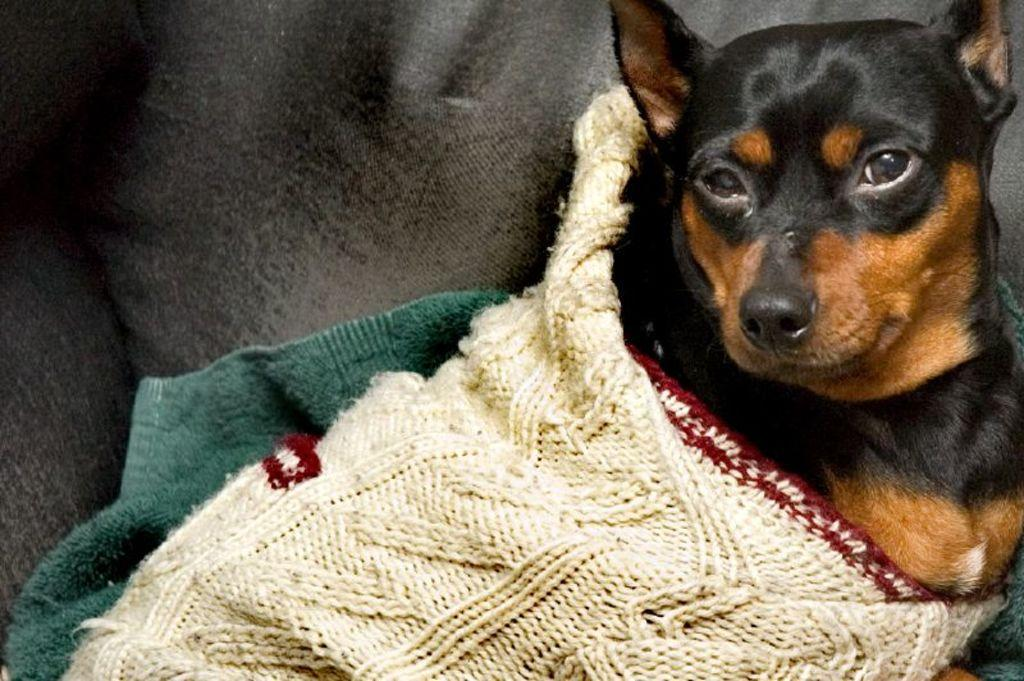What type of animal is present in the image? There is a dog in the image. What else can be seen in the image besides the dog? Clothes are visible in the image. Where is the basin located in the image? There is no basin present in the image. Who is the uncle in the image? There is no uncle mentioned or depicted in the image. 